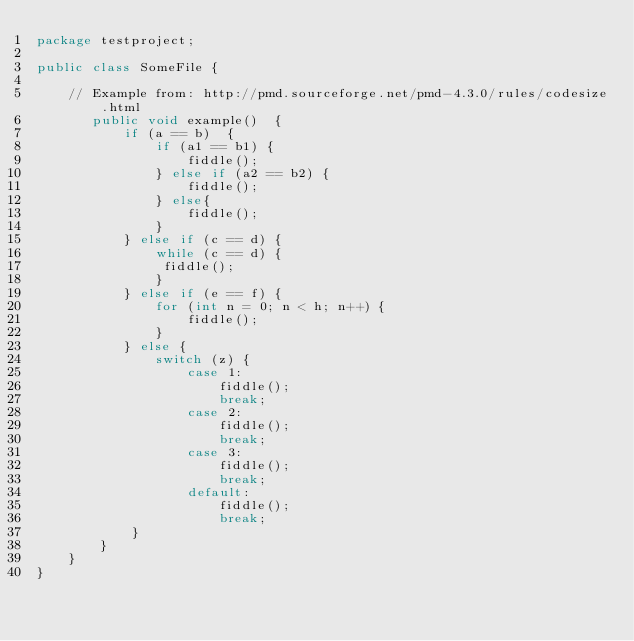<code> <loc_0><loc_0><loc_500><loc_500><_Java_>package testproject;

public class SomeFile {

    // Example from: http://pmd.sourceforge.net/pmd-4.3.0/rules/codesize.html
       public void example()  {
           if (a == b)  {
               if (a1 == b1) {
                   fiddle();
               } else if (a2 == b2) {
                   fiddle();
               } else{
                   fiddle();
               }
           } else if (c == d) {
               while (c == d) {
                fiddle();
               }
           } else if (e == f) {
               for (int n = 0; n < h; n++) {
                   fiddle();
               }
           } else {
               switch (z) {
                   case 1:
                       fiddle();
                       break;
                   case 2:
                       fiddle();
                       break;
                   case 3:
                       fiddle();
                       break;
                   default:
                       fiddle();
                       break;
            }
        }
    }
}</code> 